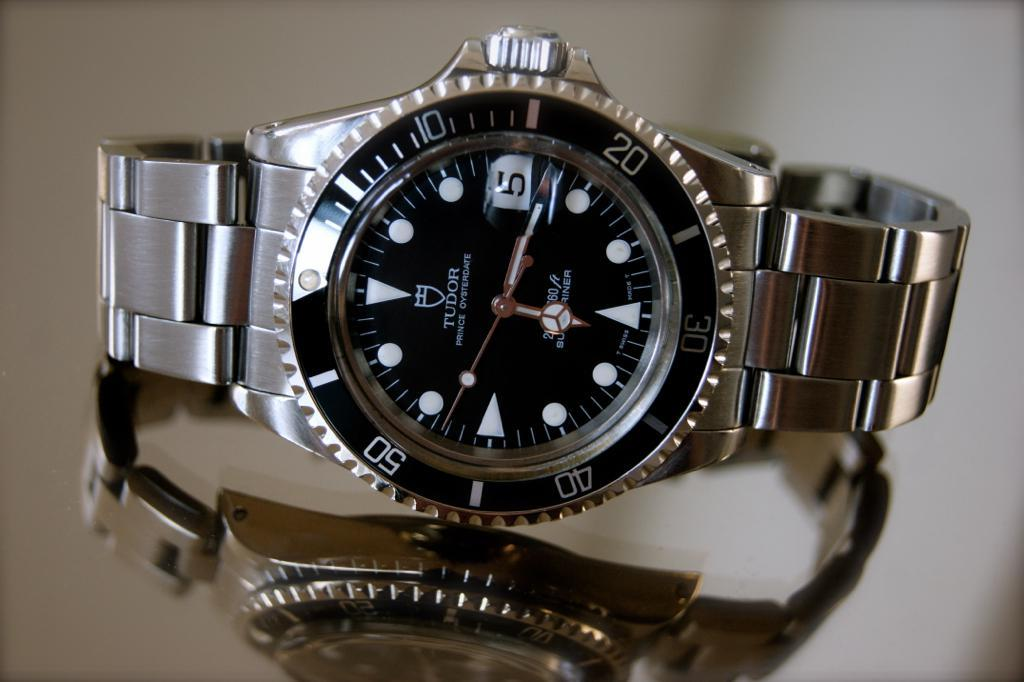<image>
Offer a succinct explanation of the picture presented. Silver and black wrist watch that has the number 5 on it. 